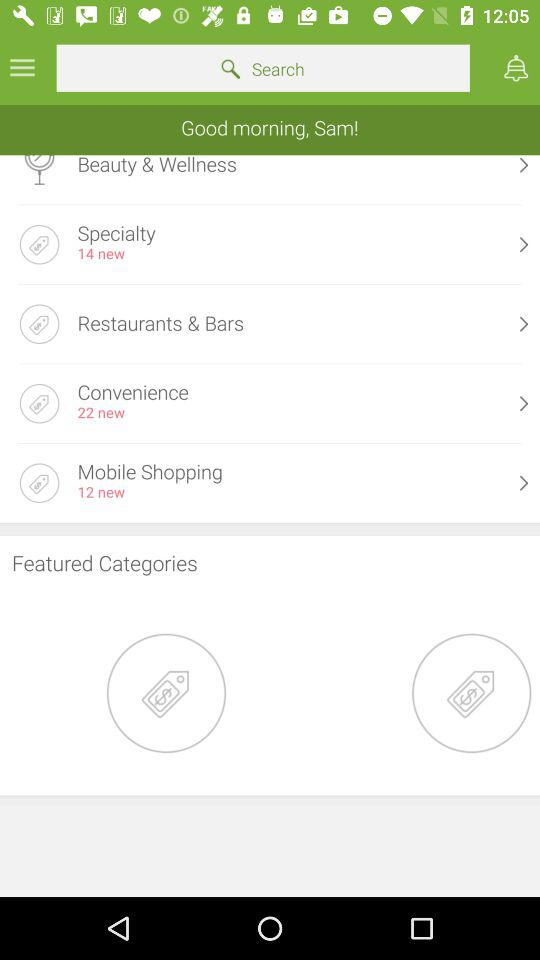How many new items in total are there in "Mobile Shopping"? There are 12 new items in "Mobile Shopping". 